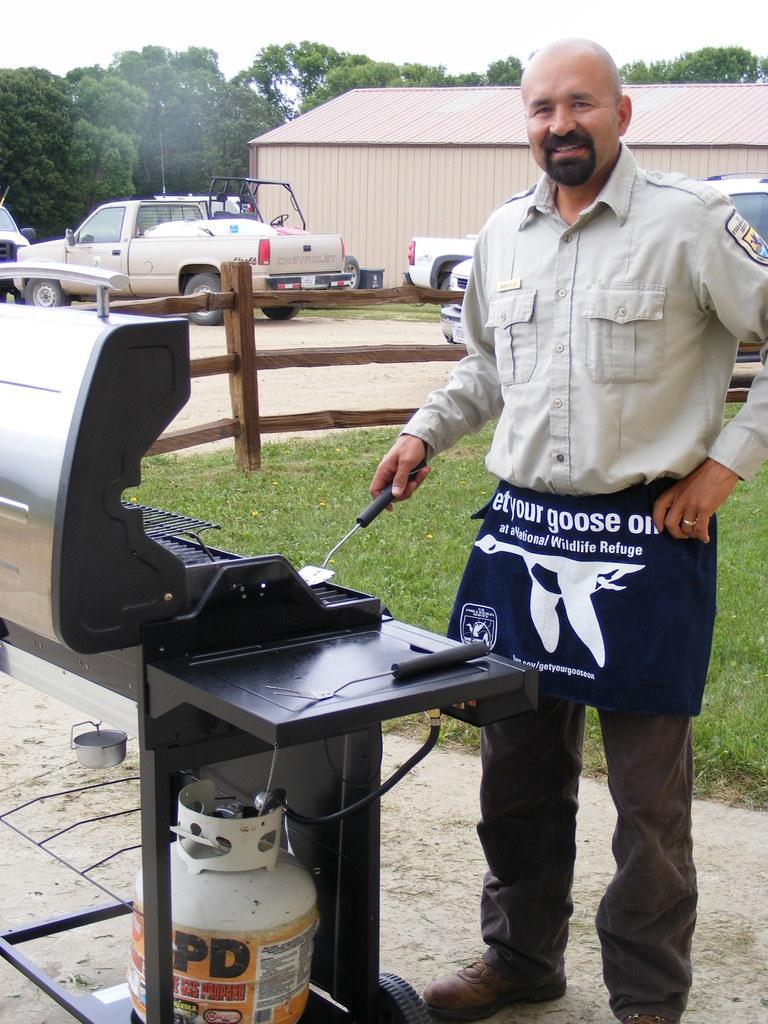<image>
Write a terse but informative summary of the picture. A man with a national wildlife refuge apron grilling 